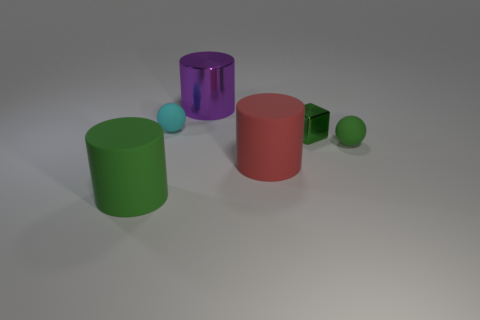What color is the other thing that is the same shape as the small green rubber thing?
Give a very brief answer. Cyan. Are there any other small cyan matte objects of the same shape as the cyan thing?
Offer a terse response. No. What is the big red object made of?
Offer a very short reply. Rubber. What is the size of the rubber object that is both behind the big red matte cylinder and on the left side of the large metallic cylinder?
Your response must be concise. Small. There is a sphere that is the same color as the small block; what is it made of?
Offer a very short reply. Rubber. How many cyan rubber balls are there?
Your answer should be compact. 1. Are there fewer big gray cubes than tiny cyan matte things?
Your answer should be very brief. Yes. There is a red object that is the same size as the purple metal cylinder; what material is it?
Your response must be concise. Rubber. How many things are either small metal balls or green blocks?
Provide a short and direct response. 1. How many small spheres are behind the tiny metallic thing and in front of the cyan matte sphere?
Give a very brief answer. 0. 